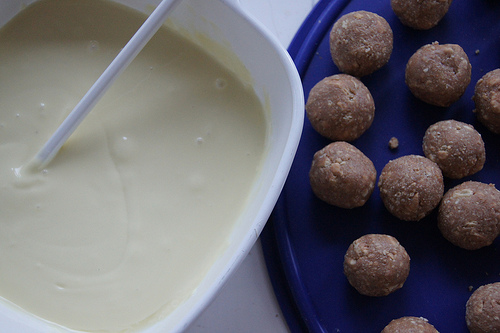<image>
Can you confirm if the spoon is in the sauce? Yes. The spoon is contained within or inside the sauce, showing a containment relationship. 